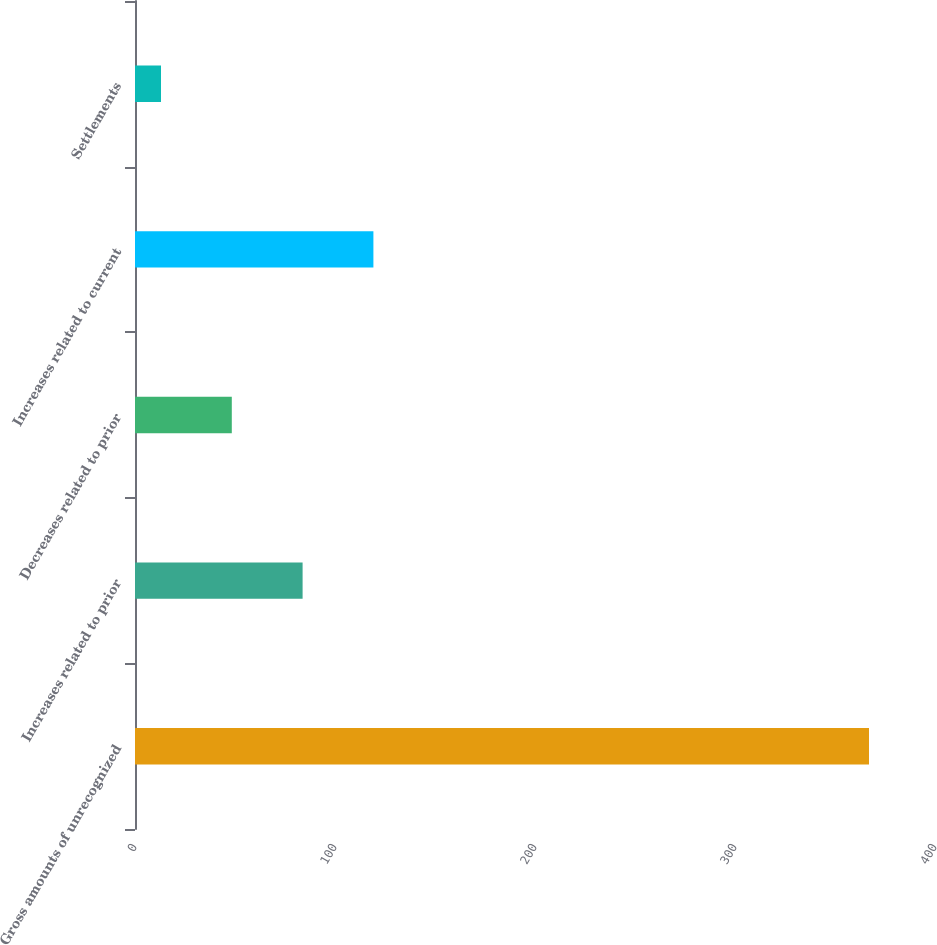Convert chart to OTSL. <chart><loc_0><loc_0><loc_500><loc_500><bar_chart><fcel>Gross amounts of unrecognized<fcel>Increases related to prior<fcel>Decreases related to prior<fcel>Increases related to current<fcel>Settlements<nl><fcel>367<fcel>83.8<fcel>48.4<fcel>119.2<fcel>13<nl></chart> 